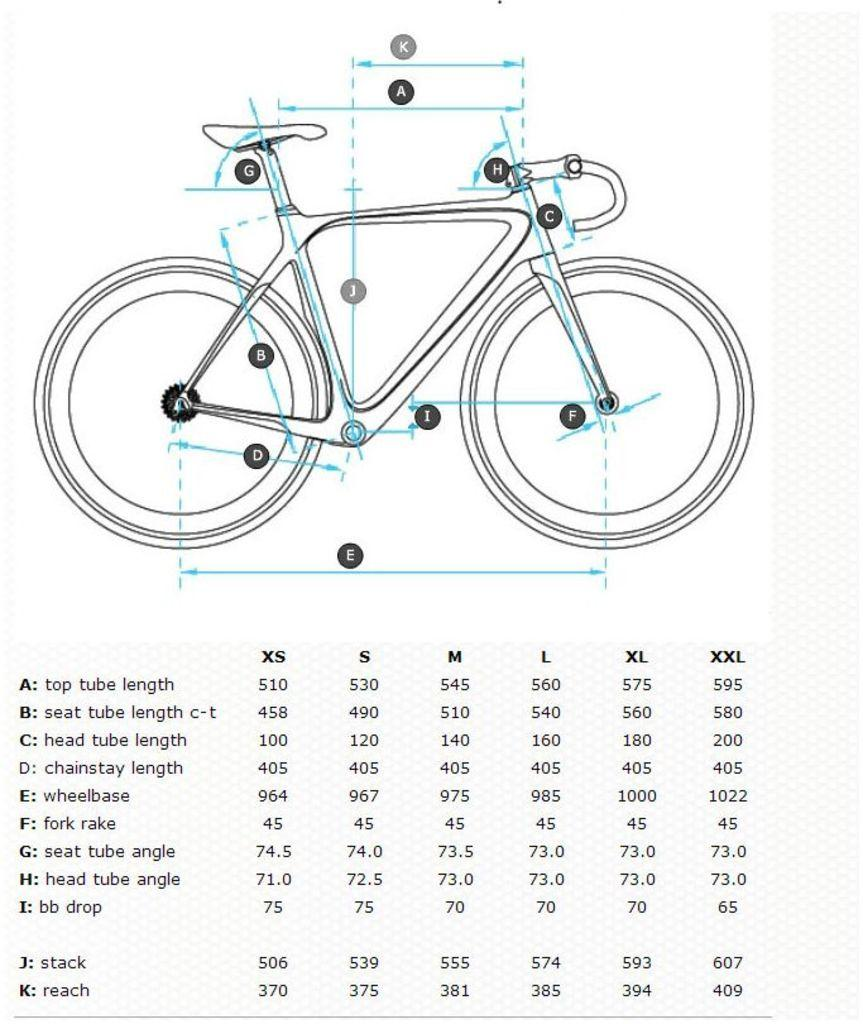<image>
Describe the image concisely. bicycle diagram with various lengths of parts such as wheelbase 